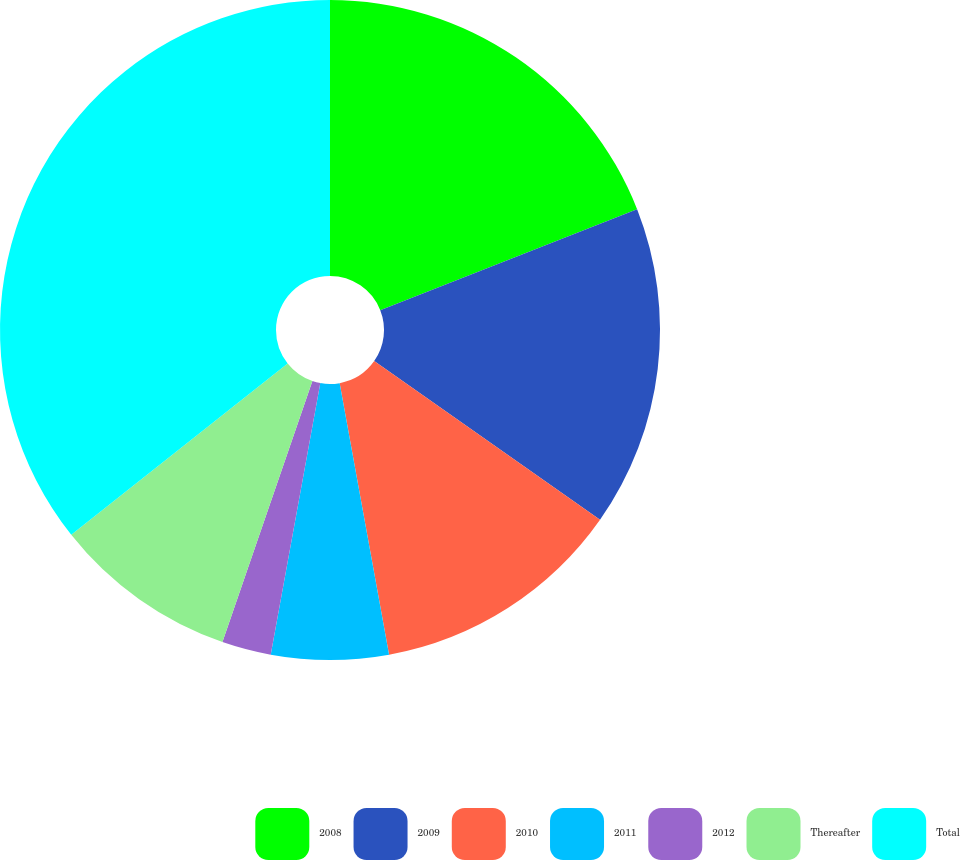<chart> <loc_0><loc_0><loc_500><loc_500><pie_chart><fcel>2008<fcel>2009<fcel>2010<fcel>2011<fcel>2012<fcel>Thereafter<fcel>Total<nl><fcel>19.04%<fcel>15.71%<fcel>12.39%<fcel>5.74%<fcel>2.41%<fcel>9.06%<fcel>35.66%<nl></chart> 